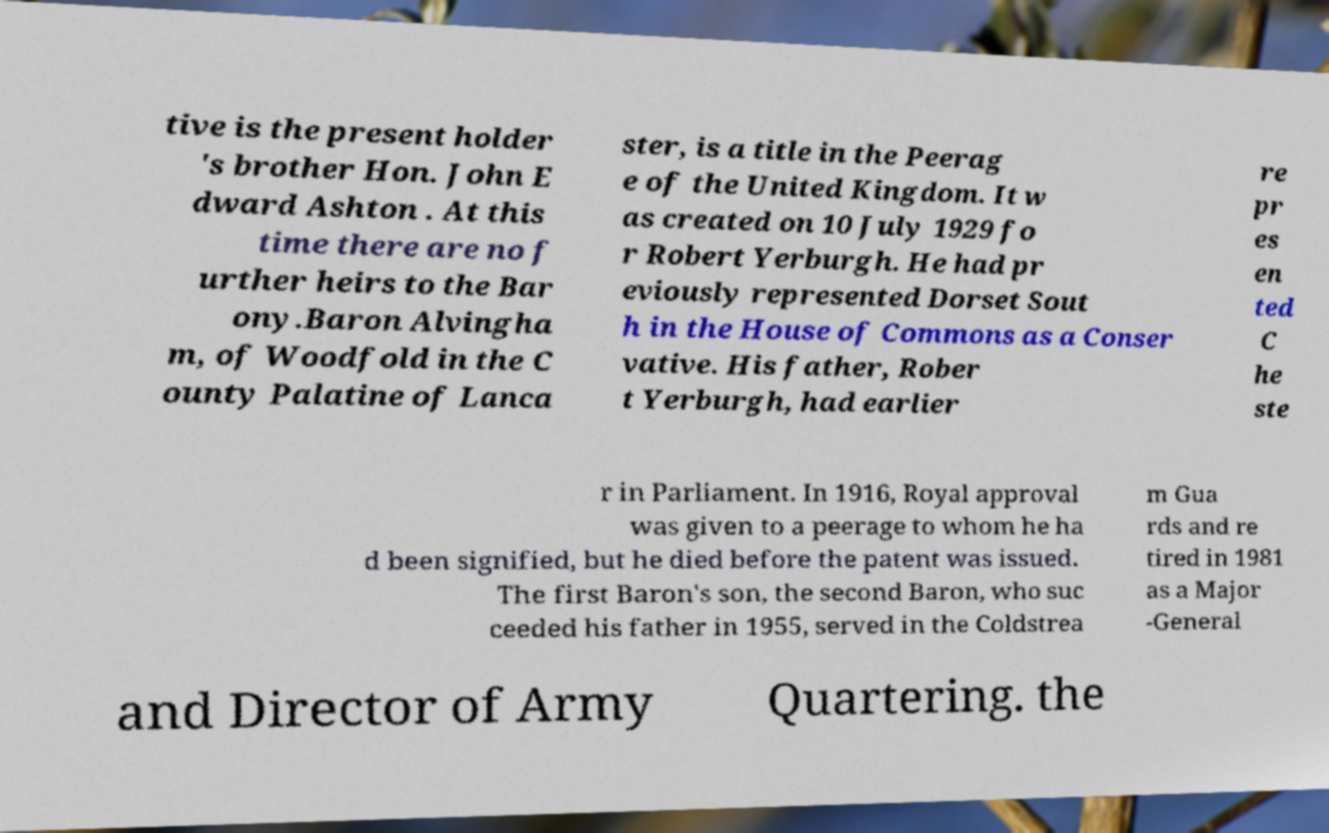I need the written content from this picture converted into text. Can you do that? tive is the present holder 's brother Hon. John E dward Ashton . At this time there are no f urther heirs to the Bar ony.Baron Alvingha m, of Woodfold in the C ounty Palatine of Lanca ster, is a title in the Peerag e of the United Kingdom. It w as created on 10 July 1929 fo r Robert Yerburgh. He had pr eviously represented Dorset Sout h in the House of Commons as a Conser vative. His father, Rober t Yerburgh, had earlier re pr es en ted C he ste r in Parliament. In 1916, Royal approval was given to a peerage to whom he ha d been signified, but he died before the patent was issued. The first Baron's son, the second Baron, who suc ceeded his father in 1955, served in the Coldstrea m Gua rds and re tired in 1981 as a Major -General and Director of Army Quartering. the 